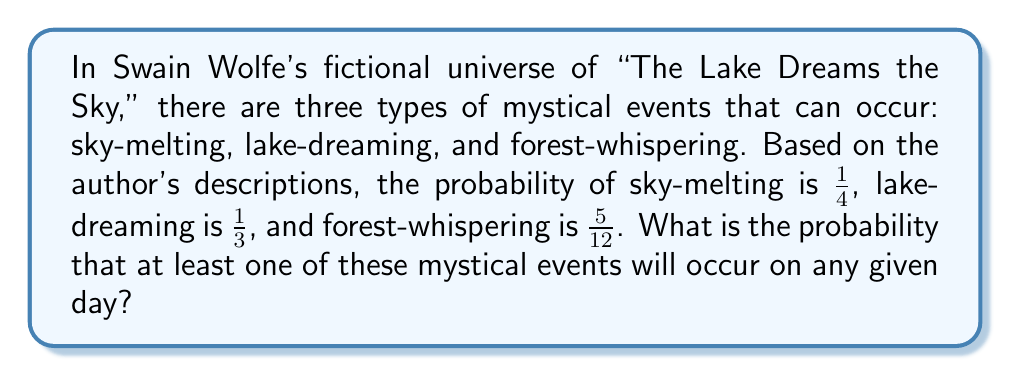Solve this math problem. To solve this problem, we'll use the concept of probability of the union of events. We need to find $P(A \cup B \cup C)$, where:

$A$ = sky-melting
$B$ = lake-dreaming
$C$ = forest-whispering

We can use the inclusion-exclusion principle:

$$P(A \cup B \cup C) = P(A) + P(B) + P(C) - P(A \cap B) - P(A \cap C) - P(B \cap C) + P(A \cap B \cap C)$$

Given:
$P(A) = \frac{1}{4}$
$P(B) = \frac{1}{3}$
$P(C) = \frac{5}{12}$

Assuming these events are independent (as they are mystical and presumably unrelated), we can calculate the intersections:

$P(A \cap B) = P(A) \cdot P(B) = \frac{1}{4} \cdot \frac{1}{3} = \frac{1}{12}$
$P(A \cap C) = P(A) \cdot P(C) = \frac{1}{4} \cdot \frac{5}{12} = \frac{5}{48}$
$P(B \cap C) = P(B) \cdot P(C) = \frac{1}{3} \cdot \frac{5}{12} = \frac{5}{36}$
$P(A \cap B \cap C) = P(A) \cdot P(B) \cdot P(C) = \frac{1}{4} \cdot \frac{1}{3} \cdot \frac{5}{12} = \frac{5}{144}$

Now, let's substitute these values into the inclusion-exclusion formula:

$$\begin{align*}
P(A \cup B \cup C) &= \frac{1}{4} + \frac{1}{3} + \frac{5}{12} - \frac{1}{12} - \frac{5}{48} - \frac{5}{36} + \frac{5}{144} \\[10pt]
&= \frac{3}{12} + \frac{4}{12} + \frac{5}{12} - \frac{1}{12} - \frac{5}{48} - \frac{5}{36} + \frac{5}{144} \\[10pt]
&= \frac{12}{12} - \frac{5}{48} - \frac{5}{36} + \frac{5}{144} \\[10pt]
&= 1 - \frac{15}{144} - \frac{20}{144} + \frac{5}{144} \\[10pt]
&= 1 - \frac{30}{144} \\[10pt]
&= 1 - \frac{5}{24} \\[10pt]
&= \frac{24}{24} - \frac{5}{24} \\[10pt]
&= \frac{19}{24}
\end{align*}$$
Answer: The probability that at least one of these mystical events will occur on any given day is $\frac{19}{24}$ or approximately 0.7917 (79.17%). 